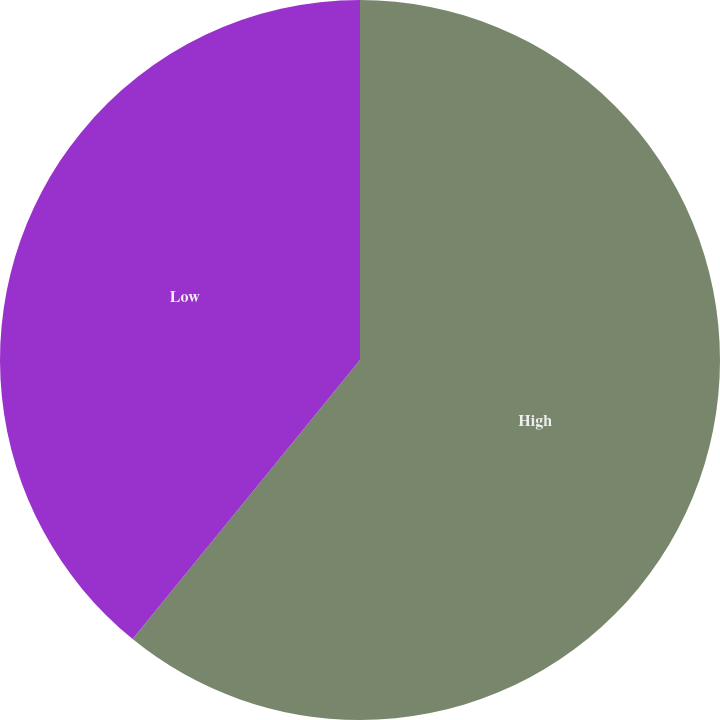<chart> <loc_0><loc_0><loc_500><loc_500><pie_chart><fcel>High<fcel>Low<nl><fcel>60.88%<fcel>39.12%<nl></chart> 